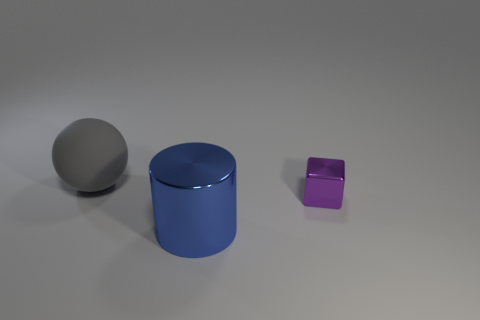Add 2 big green rubber blocks. How many objects exist? 5 Subtract all cylinders. How many objects are left? 2 Add 1 big gray balls. How many big gray balls are left? 2 Add 2 tiny red spheres. How many tiny red spheres exist? 2 Subtract 1 gray spheres. How many objects are left? 2 Subtract all large blue metallic things. Subtract all big green spheres. How many objects are left? 2 